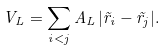Convert formula to latex. <formula><loc_0><loc_0><loc_500><loc_500>V _ { L } = \sum _ { i < j } A _ { L } \, | \vec { r } _ { i } - \vec { r } _ { j } | .</formula> 